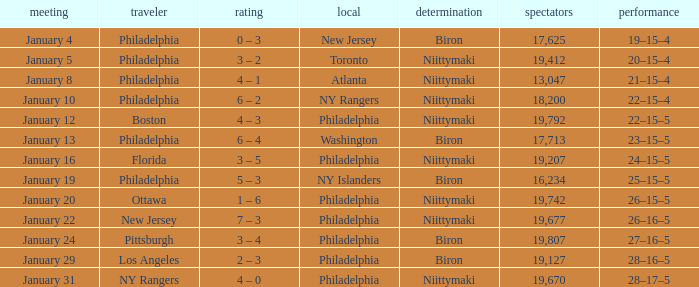What was the date that the decision was Niittymaki, the attendance larger than 19,207, and the record 28–17–5? January 31. 